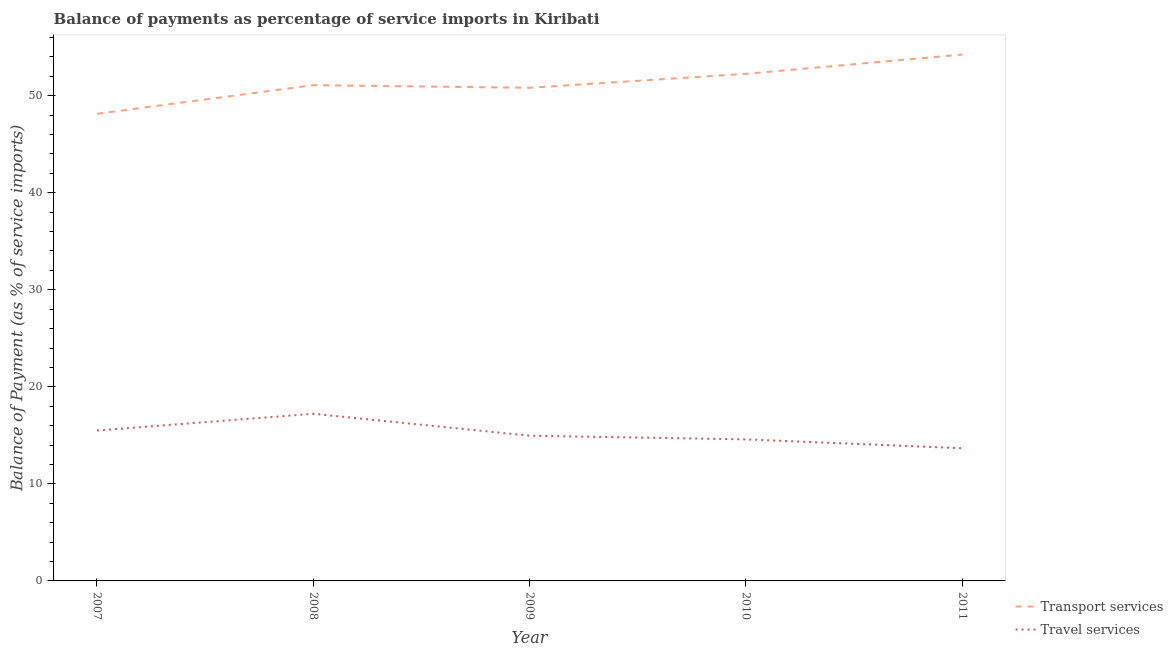Is the number of lines equal to the number of legend labels?
Offer a terse response. Yes. What is the balance of payments of travel services in 2008?
Your response must be concise. 17.22. Across all years, what is the maximum balance of payments of travel services?
Offer a very short reply. 17.22. Across all years, what is the minimum balance of payments of travel services?
Your response must be concise. 13.67. What is the total balance of payments of travel services in the graph?
Provide a short and direct response. 75.94. What is the difference between the balance of payments of transport services in 2010 and that in 2011?
Make the answer very short. -1.99. What is the difference between the balance of payments of transport services in 2010 and the balance of payments of travel services in 2011?
Ensure brevity in your answer.  38.58. What is the average balance of payments of travel services per year?
Give a very brief answer. 15.19. In the year 2007, what is the difference between the balance of payments of transport services and balance of payments of travel services?
Provide a succinct answer. 32.64. In how many years, is the balance of payments of transport services greater than 40 %?
Keep it short and to the point. 5. What is the ratio of the balance of payments of travel services in 2008 to that in 2009?
Offer a terse response. 1.15. What is the difference between the highest and the second highest balance of payments of transport services?
Make the answer very short. 1.99. What is the difference between the highest and the lowest balance of payments of transport services?
Your answer should be very brief. 6.1. In how many years, is the balance of payments of transport services greater than the average balance of payments of transport services taken over all years?
Provide a short and direct response. 2. Does the balance of payments of travel services monotonically increase over the years?
Your answer should be very brief. No. Is the balance of payments of travel services strictly less than the balance of payments of transport services over the years?
Offer a very short reply. Yes. How many lines are there?
Your answer should be compact. 2. What is the difference between two consecutive major ticks on the Y-axis?
Your answer should be compact. 10. Where does the legend appear in the graph?
Provide a short and direct response. Bottom right. How many legend labels are there?
Provide a succinct answer. 2. How are the legend labels stacked?
Ensure brevity in your answer.  Vertical. What is the title of the graph?
Your answer should be very brief. Balance of payments as percentage of service imports in Kiribati. Does "2012 US$" appear as one of the legend labels in the graph?
Offer a terse response. No. What is the label or title of the X-axis?
Offer a very short reply. Year. What is the label or title of the Y-axis?
Your answer should be compact. Balance of Payment (as % of service imports). What is the Balance of Payment (as % of service imports) of Transport services in 2007?
Offer a very short reply. 48.13. What is the Balance of Payment (as % of service imports) in Travel services in 2007?
Your answer should be compact. 15.5. What is the Balance of Payment (as % of service imports) of Transport services in 2008?
Offer a very short reply. 51.08. What is the Balance of Payment (as % of service imports) in Travel services in 2008?
Give a very brief answer. 17.22. What is the Balance of Payment (as % of service imports) in Transport services in 2009?
Offer a terse response. 50.81. What is the Balance of Payment (as % of service imports) of Travel services in 2009?
Offer a terse response. 14.96. What is the Balance of Payment (as % of service imports) in Transport services in 2010?
Make the answer very short. 52.25. What is the Balance of Payment (as % of service imports) of Travel services in 2010?
Ensure brevity in your answer.  14.58. What is the Balance of Payment (as % of service imports) of Transport services in 2011?
Your response must be concise. 54.24. What is the Balance of Payment (as % of service imports) in Travel services in 2011?
Provide a succinct answer. 13.67. Across all years, what is the maximum Balance of Payment (as % of service imports) in Transport services?
Your response must be concise. 54.24. Across all years, what is the maximum Balance of Payment (as % of service imports) of Travel services?
Offer a terse response. 17.22. Across all years, what is the minimum Balance of Payment (as % of service imports) in Transport services?
Keep it short and to the point. 48.13. Across all years, what is the minimum Balance of Payment (as % of service imports) of Travel services?
Your response must be concise. 13.67. What is the total Balance of Payment (as % of service imports) of Transport services in the graph?
Make the answer very short. 256.52. What is the total Balance of Payment (as % of service imports) of Travel services in the graph?
Your response must be concise. 75.94. What is the difference between the Balance of Payment (as % of service imports) of Transport services in 2007 and that in 2008?
Offer a terse response. -2.95. What is the difference between the Balance of Payment (as % of service imports) of Travel services in 2007 and that in 2008?
Provide a short and direct response. -1.72. What is the difference between the Balance of Payment (as % of service imports) in Transport services in 2007 and that in 2009?
Your answer should be compact. -2.68. What is the difference between the Balance of Payment (as % of service imports) in Travel services in 2007 and that in 2009?
Provide a short and direct response. 0.53. What is the difference between the Balance of Payment (as % of service imports) in Transport services in 2007 and that in 2010?
Your answer should be very brief. -4.12. What is the difference between the Balance of Payment (as % of service imports) in Travel services in 2007 and that in 2010?
Keep it short and to the point. 0.91. What is the difference between the Balance of Payment (as % of service imports) in Transport services in 2007 and that in 2011?
Offer a terse response. -6.1. What is the difference between the Balance of Payment (as % of service imports) of Travel services in 2007 and that in 2011?
Provide a short and direct response. 1.83. What is the difference between the Balance of Payment (as % of service imports) of Transport services in 2008 and that in 2009?
Offer a very short reply. 0.27. What is the difference between the Balance of Payment (as % of service imports) in Travel services in 2008 and that in 2009?
Your answer should be very brief. 2.26. What is the difference between the Balance of Payment (as % of service imports) in Transport services in 2008 and that in 2010?
Your answer should be compact. -1.17. What is the difference between the Balance of Payment (as % of service imports) of Travel services in 2008 and that in 2010?
Give a very brief answer. 2.64. What is the difference between the Balance of Payment (as % of service imports) in Transport services in 2008 and that in 2011?
Offer a terse response. -3.15. What is the difference between the Balance of Payment (as % of service imports) in Travel services in 2008 and that in 2011?
Offer a terse response. 3.55. What is the difference between the Balance of Payment (as % of service imports) in Transport services in 2009 and that in 2010?
Keep it short and to the point. -1.44. What is the difference between the Balance of Payment (as % of service imports) of Travel services in 2009 and that in 2010?
Provide a succinct answer. 0.38. What is the difference between the Balance of Payment (as % of service imports) of Transport services in 2009 and that in 2011?
Your answer should be compact. -3.42. What is the difference between the Balance of Payment (as % of service imports) of Travel services in 2009 and that in 2011?
Make the answer very short. 1.29. What is the difference between the Balance of Payment (as % of service imports) of Transport services in 2010 and that in 2011?
Ensure brevity in your answer.  -1.99. What is the difference between the Balance of Payment (as % of service imports) of Travel services in 2010 and that in 2011?
Ensure brevity in your answer.  0.91. What is the difference between the Balance of Payment (as % of service imports) in Transport services in 2007 and the Balance of Payment (as % of service imports) in Travel services in 2008?
Your answer should be compact. 30.91. What is the difference between the Balance of Payment (as % of service imports) of Transport services in 2007 and the Balance of Payment (as % of service imports) of Travel services in 2009?
Ensure brevity in your answer.  33.17. What is the difference between the Balance of Payment (as % of service imports) of Transport services in 2007 and the Balance of Payment (as % of service imports) of Travel services in 2010?
Provide a succinct answer. 33.55. What is the difference between the Balance of Payment (as % of service imports) in Transport services in 2007 and the Balance of Payment (as % of service imports) in Travel services in 2011?
Ensure brevity in your answer.  34.46. What is the difference between the Balance of Payment (as % of service imports) in Transport services in 2008 and the Balance of Payment (as % of service imports) in Travel services in 2009?
Make the answer very short. 36.12. What is the difference between the Balance of Payment (as % of service imports) of Transport services in 2008 and the Balance of Payment (as % of service imports) of Travel services in 2010?
Offer a very short reply. 36.5. What is the difference between the Balance of Payment (as % of service imports) of Transport services in 2008 and the Balance of Payment (as % of service imports) of Travel services in 2011?
Provide a short and direct response. 37.41. What is the difference between the Balance of Payment (as % of service imports) in Transport services in 2009 and the Balance of Payment (as % of service imports) in Travel services in 2010?
Provide a succinct answer. 36.23. What is the difference between the Balance of Payment (as % of service imports) in Transport services in 2009 and the Balance of Payment (as % of service imports) in Travel services in 2011?
Your answer should be compact. 37.14. What is the difference between the Balance of Payment (as % of service imports) of Transport services in 2010 and the Balance of Payment (as % of service imports) of Travel services in 2011?
Your answer should be compact. 38.58. What is the average Balance of Payment (as % of service imports) of Transport services per year?
Your answer should be very brief. 51.3. What is the average Balance of Payment (as % of service imports) of Travel services per year?
Your answer should be compact. 15.19. In the year 2007, what is the difference between the Balance of Payment (as % of service imports) of Transport services and Balance of Payment (as % of service imports) of Travel services?
Make the answer very short. 32.64. In the year 2008, what is the difference between the Balance of Payment (as % of service imports) of Transport services and Balance of Payment (as % of service imports) of Travel services?
Your answer should be compact. 33.86. In the year 2009, what is the difference between the Balance of Payment (as % of service imports) of Transport services and Balance of Payment (as % of service imports) of Travel services?
Provide a short and direct response. 35.85. In the year 2010, what is the difference between the Balance of Payment (as % of service imports) of Transport services and Balance of Payment (as % of service imports) of Travel services?
Provide a succinct answer. 37.67. In the year 2011, what is the difference between the Balance of Payment (as % of service imports) of Transport services and Balance of Payment (as % of service imports) of Travel services?
Make the answer very short. 40.56. What is the ratio of the Balance of Payment (as % of service imports) in Transport services in 2007 to that in 2008?
Provide a short and direct response. 0.94. What is the ratio of the Balance of Payment (as % of service imports) in Travel services in 2007 to that in 2008?
Provide a short and direct response. 0.9. What is the ratio of the Balance of Payment (as % of service imports) of Transport services in 2007 to that in 2009?
Your answer should be compact. 0.95. What is the ratio of the Balance of Payment (as % of service imports) of Travel services in 2007 to that in 2009?
Provide a short and direct response. 1.04. What is the ratio of the Balance of Payment (as % of service imports) in Transport services in 2007 to that in 2010?
Offer a terse response. 0.92. What is the ratio of the Balance of Payment (as % of service imports) of Travel services in 2007 to that in 2010?
Give a very brief answer. 1.06. What is the ratio of the Balance of Payment (as % of service imports) in Transport services in 2007 to that in 2011?
Give a very brief answer. 0.89. What is the ratio of the Balance of Payment (as % of service imports) of Travel services in 2007 to that in 2011?
Ensure brevity in your answer.  1.13. What is the ratio of the Balance of Payment (as % of service imports) in Travel services in 2008 to that in 2009?
Offer a terse response. 1.15. What is the ratio of the Balance of Payment (as % of service imports) in Transport services in 2008 to that in 2010?
Your answer should be very brief. 0.98. What is the ratio of the Balance of Payment (as % of service imports) in Travel services in 2008 to that in 2010?
Keep it short and to the point. 1.18. What is the ratio of the Balance of Payment (as % of service imports) in Transport services in 2008 to that in 2011?
Give a very brief answer. 0.94. What is the ratio of the Balance of Payment (as % of service imports) in Travel services in 2008 to that in 2011?
Keep it short and to the point. 1.26. What is the ratio of the Balance of Payment (as % of service imports) in Transport services in 2009 to that in 2010?
Ensure brevity in your answer.  0.97. What is the ratio of the Balance of Payment (as % of service imports) in Transport services in 2009 to that in 2011?
Offer a very short reply. 0.94. What is the ratio of the Balance of Payment (as % of service imports) in Travel services in 2009 to that in 2011?
Offer a very short reply. 1.09. What is the ratio of the Balance of Payment (as % of service imports) of Transport services in 2010 to that in 2011?
Offer a very short reply. 0.96. What is the ratio of the Balance of Payment (as % of service imports) of Travel services in 2010 to that in 2011?
Give a very brief answer. 1.07. What is the difference between the highest and the second highest Balance of Payment (as % of service imports) in Transport services?
Offer a very short reply. 1.99. What is the difference between the highest and the second highest Balance of Payment (as % of service imports) of Travel services?
Give a very brief answer. 1.72. What is the difference between the highest and the lowest Balance of Payment (as % of service imports) of Transport services?
Your answer should be compact. 6.1. What is the difference between the highest and the lowest Balance of Payment (as % of service imports) in Travel services?
Offer a very short reply. 3.55. 